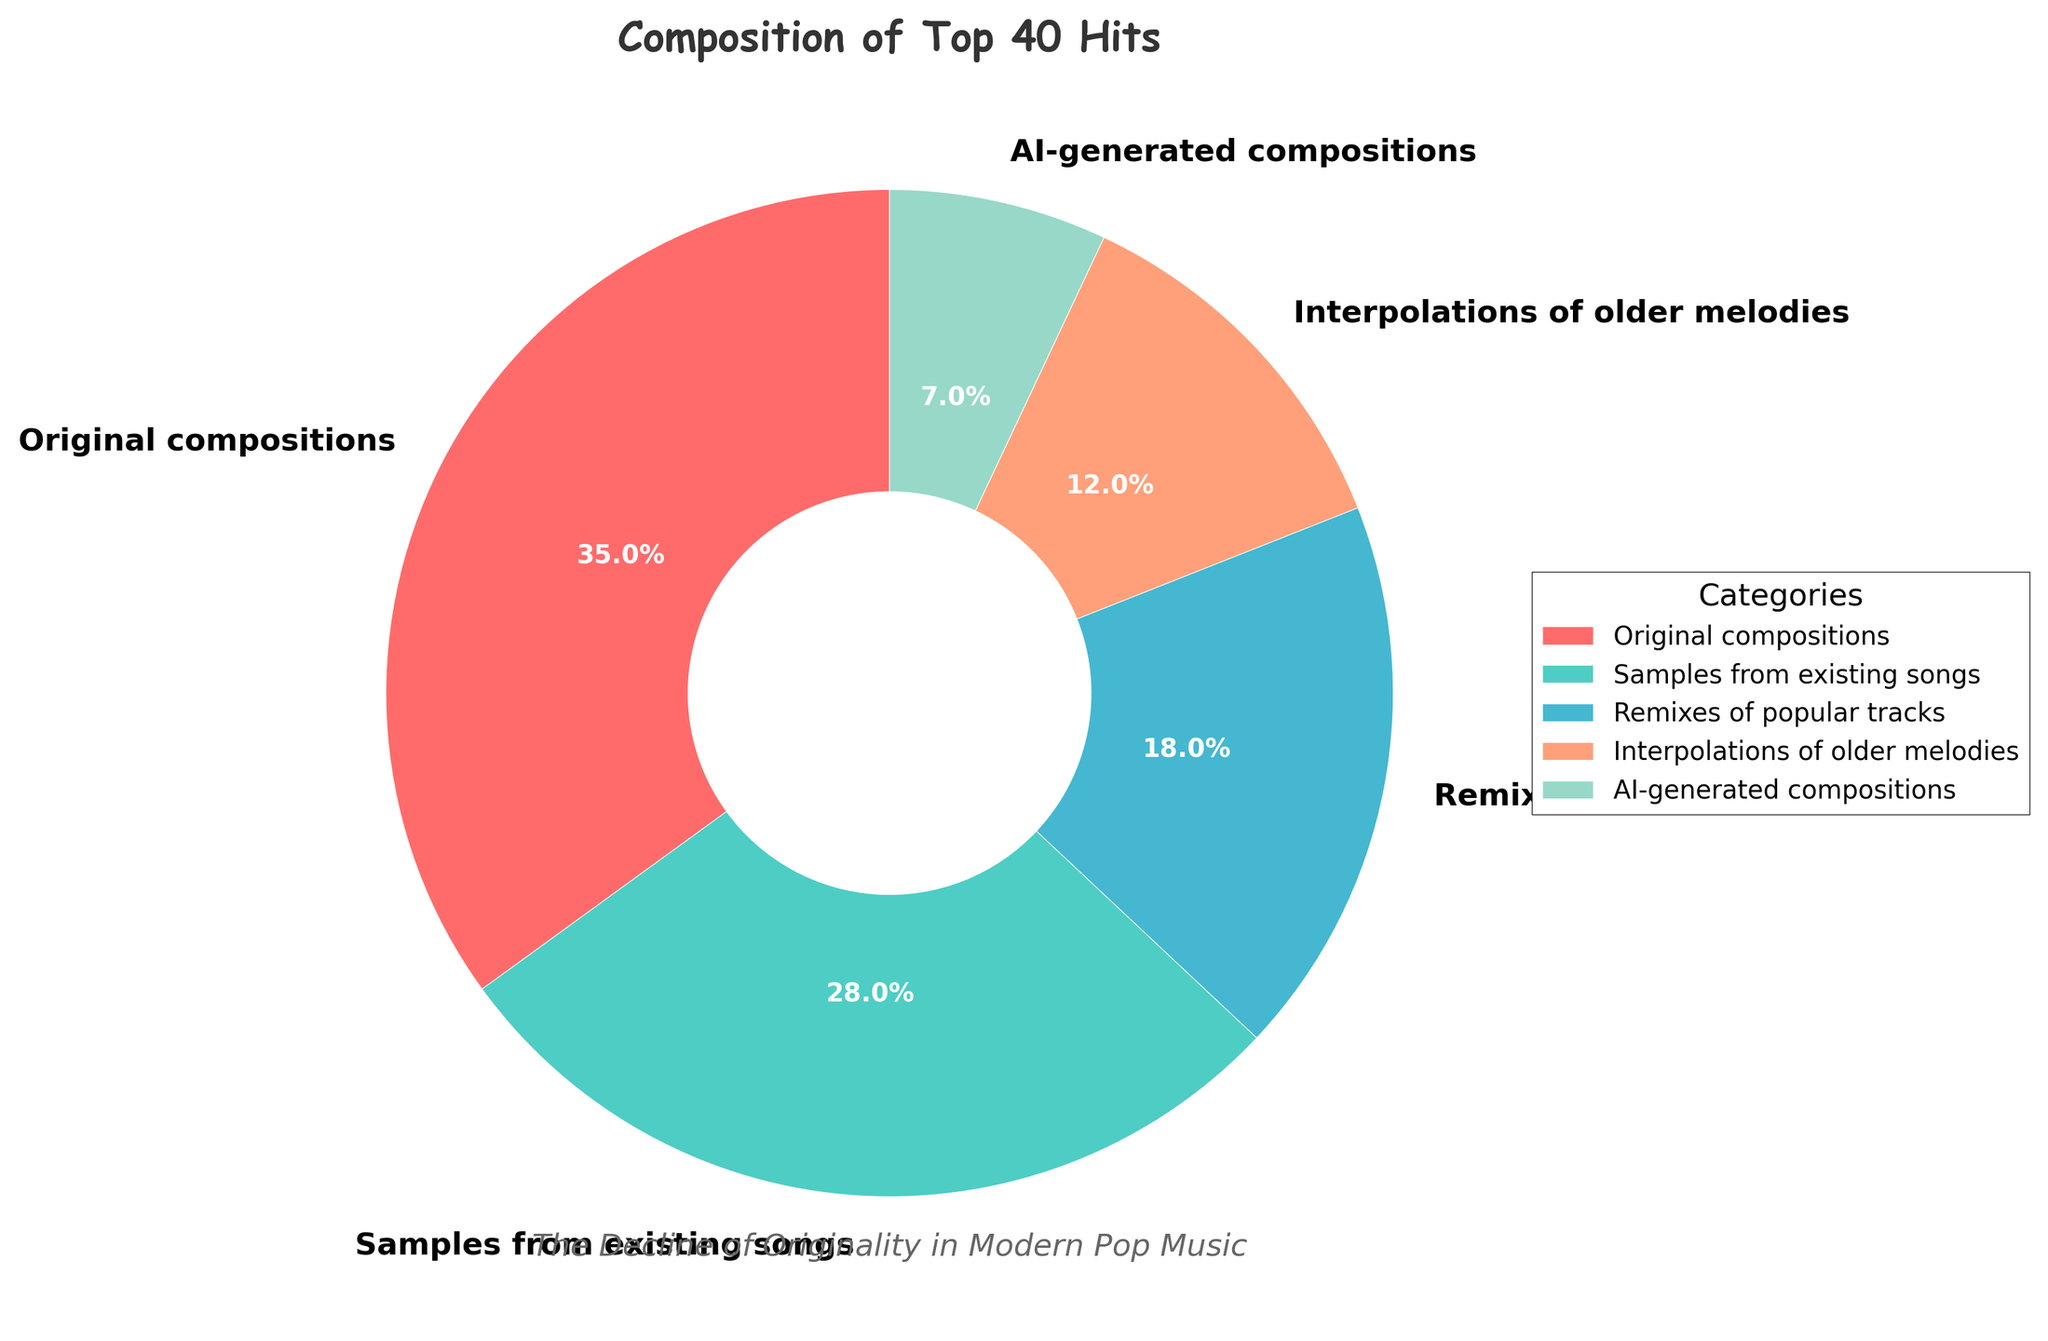What category has the highest percentage? The section of the pie chart with "Original compositions" is the largest, taking up 35% as indicated on the chart.
Answer: Original compositions Which category contributes more to the top 40 hits: samples from existing songs or AI-generated compositions? Comparing the percentages, "Samples from existing songs" at 28% is higher than "AI-generated compositions" at 7%.
Answer: Samples from existing songs What is the combined percentage of samples and remixes? Adding the percentages of "Samples from existing songs" (28%) and "Remixes of popular tracks" (18%) gives 28 + 18 = 46%.
Answer: 46% How does the percentage of original compositions compare to that of interpolations of older melodies? The percentage of "Original compositions" at 35% is higher than "Interpolations of older melodies" at 12% by a difference of 35 - 12 = 23%.
Answer: 23% What is the total percentage of non-original compositions? Adding the percentages of non-original categories: 28% (Samples) + 18% (Remixes) + 12% (Interpolations) + 7% (AI-generated) = 65%.
Answer: 65% Which two categories together make up nearly half of the total percentage? "Samples from existing songs" (28%) and "Remixes of popular tracks" (18%) combine to 28 + 18 = 46%, which is close to half.
Answer: Samples from existing songs and Remixes of popular tracks What fraction of the chart is dedicated to original compositions? With "Original compositions" at 35%, this translates to 35/100 or 35 out of 100 parts of the chart.
Answer: 35 out of 100 If you sum up the percentages of original compositions, interpolations of older melodies, and AI-generated compositions, what's the result? Adding 35% (Original) + 12% (Interpolations) + 7% (AI-generated) results in 35 + 12 + 7 = 54%.
Answer: 54% Which category has the smallest slice, and what is its percentage? The smallest slice of the pie chart, indicated by its size and label, is "AI-generated compositions" at 7%.
Answer: AI-generated compositions, 7% Visualize the second and third largest categories in terms of percentage. What are these categories and their respective percentages? The second largest category is "Samples from existing songs" (28%) and the third largest is "Remixes of popular tracks" (18%), as visually represented by the size of their slices.
Answer: Samples from existing songs (28%) and Remixes of popular tracks (18%) 